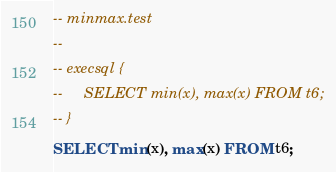Convert code to text. <code><loc_0><loc_0><loc_500><loc_500><_SQL_>-- minmax.test
-- 
-- execsql {
--     SELECT min(x), max(x) FROM t6;
-- }
SELECT min(x), max(x) FROM t6;</code> 